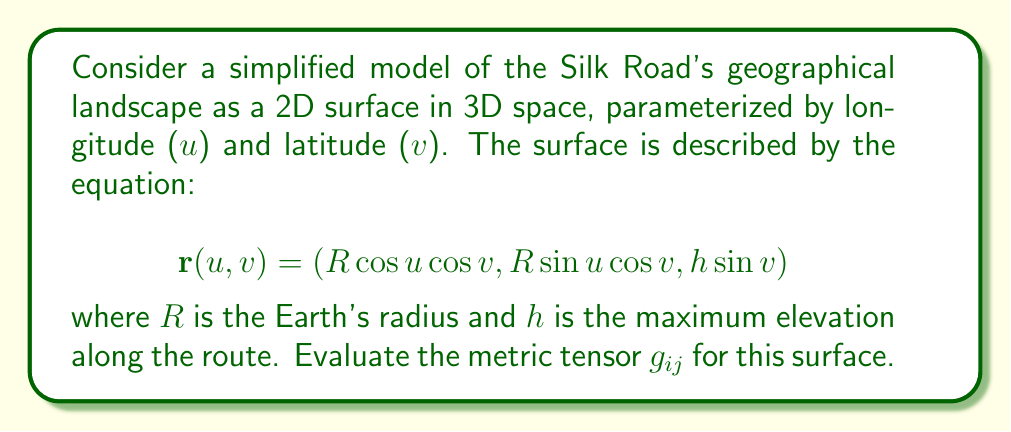Teach me how to tackle this problem. To find the metric tensor, we follow these steps:

1) The metric tensor $g_{ij}$ is defined as the dot product of partial derivatives:

   $$g_{ij} = \frac{\partial \mathbf{r}}{\partial x^i} \cdot \frac{\partial \mathbf{r}}{\partial x^j}$$

   where $x^1 = u$ and $x^2 = v$.

2) Calculate the partial derivatives:

   $$\frac{\partial \mathbf{r}}{\partial u} = (-R \sin u \cos v, R \cos u \cos v, 0)$$
   $$\frac{\partial \mathbf{r}}{\partial v} = (-R \cos u \sin v, -R \sin u \sin v, h \cos v)$$

3) Compute the dot products:

   $g_{11} = \frac{\partial \mathbf{r}}{\partial u} \cdot \frac{\partial \mathbf{r}}{\partial u}$
   $= R^2 \sin^2 u \cos^2 v + R^2 \cos^2 u \cos^2 v$
   $= R^2 \cos^2 v$

   $g_{22} = \frac{\partial \mathbf{r}}{\partial v} \cdot \frac{\partial \mathbf{r}}{\partial v}$
   $= R^2 \cos^2 u \sin^2 v + R^2 \sin^2 u \sin^2 v + h^2 \cos^2 v$
   $= R^2 \sin^2 v + h^2 \cos^2 v$

   $g_{12} = g_{21} = \frac{\partial \mathbf{r}}{\partial u} \cdot \frac{\partial \mathbf{r}}{\partial v}$
   $= R^2 \sin u \cos u \sin v \cos v - R^2 \cos u \sin u \sin v \cos v = 0$

4) The metric tensor is therefore:

   $$g_{ij} = \begin{pmatrix}
   R^2 \cos^2 v & 0 \\
   0 & R^2 \sin^2 v + h^2 \cos^2 v
   \end{pmatrix}$$

This metric tensor describes the geometry of our simplified Silk Road landscape model.
Answer: $$g_{ij} = \begin{pmatrix}
R^2 \cos^2 v & 0 \\
0 & R^2 \sin^2 v + h^2 \cos^2 v
\end{pmatrix}$$ 